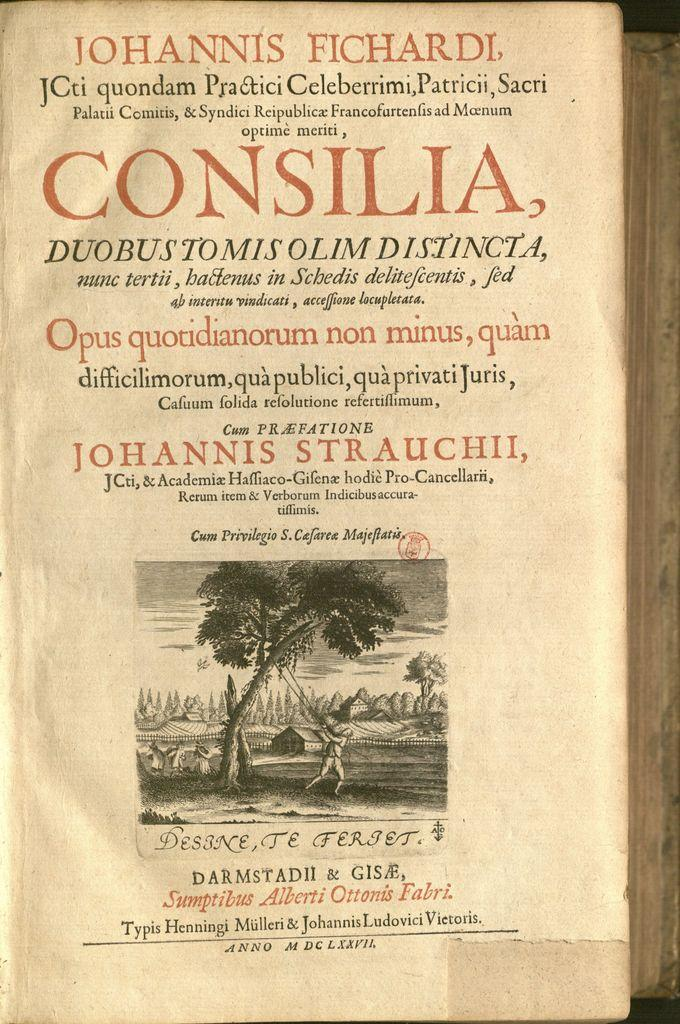<image>
Offer a succinct explanation of the picture presented. The cover page of the book "Consilia" by Johannis Fichardi. 